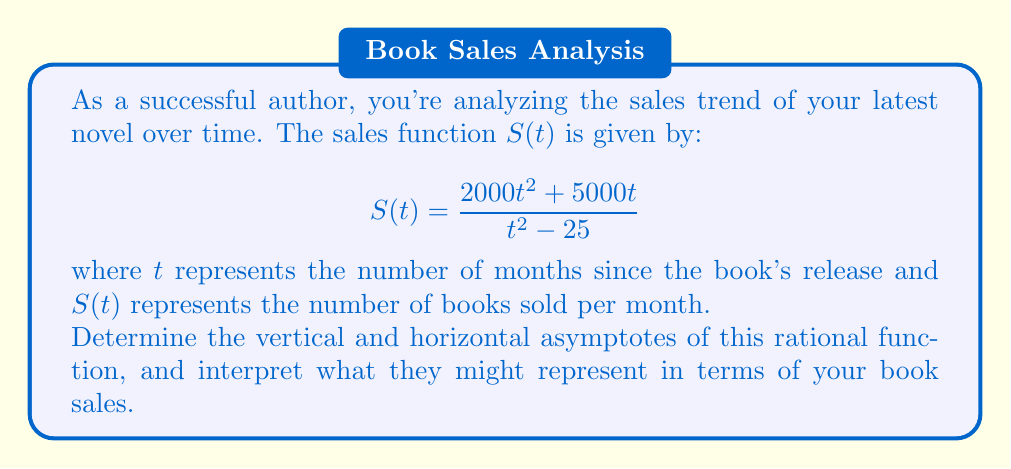Can you solve this math problem? Let's analyze this rational function step by step:

1) To find the horizontal asymptote, we compare the degrees of the numerator and denominator:
   - Numerator degree: 2
   - Denominator degree: 2
   Since they're equal, the horizontal asymptote is the ratio of the leading coefficients:
   $$\lim_{t \to \infty} S(t) = \frac{2000}{1} = 2000$$

2) For vertical asymptotes, we set the denominator to zero:
   $$t^2 - 25 = 0$$
   $$(t+5)(t-5) = 0$$
   $$t = \pm 5$$

3) To confirm these are indeed asymptotes, let's check the limits:
   As $t$ approaches 5 from both sides:
   $$\lim_{t \to 5^-} S(t) = -\infty \quad \text{and} \quad \lim_{t \to 5^+} S(t) = +\infty$$
   As $t$ approaches -5 from both sides:
   $$\lim_{t \to -5^-} S(t) = +\infty \quad \text{and} \quad \lim_{t \to -5^+} S(t) = -\infty$$

Interpretation:
- The horizontal asymptote at $y = 2000$ suggests that in the long term, your book sales might stabilize at around 2000 books per month.
- The vertical asymptotes at $t = \pm 5$ indicate potential "critical points" at 5 months before and after the book's release. These could represent significant events affecting sales, such as a major marketing campaign or the release of a sequel.
Answer: Horizontal asymptote: $y = 2000$; Vertical asymptotes: $t = \pm 5$ 